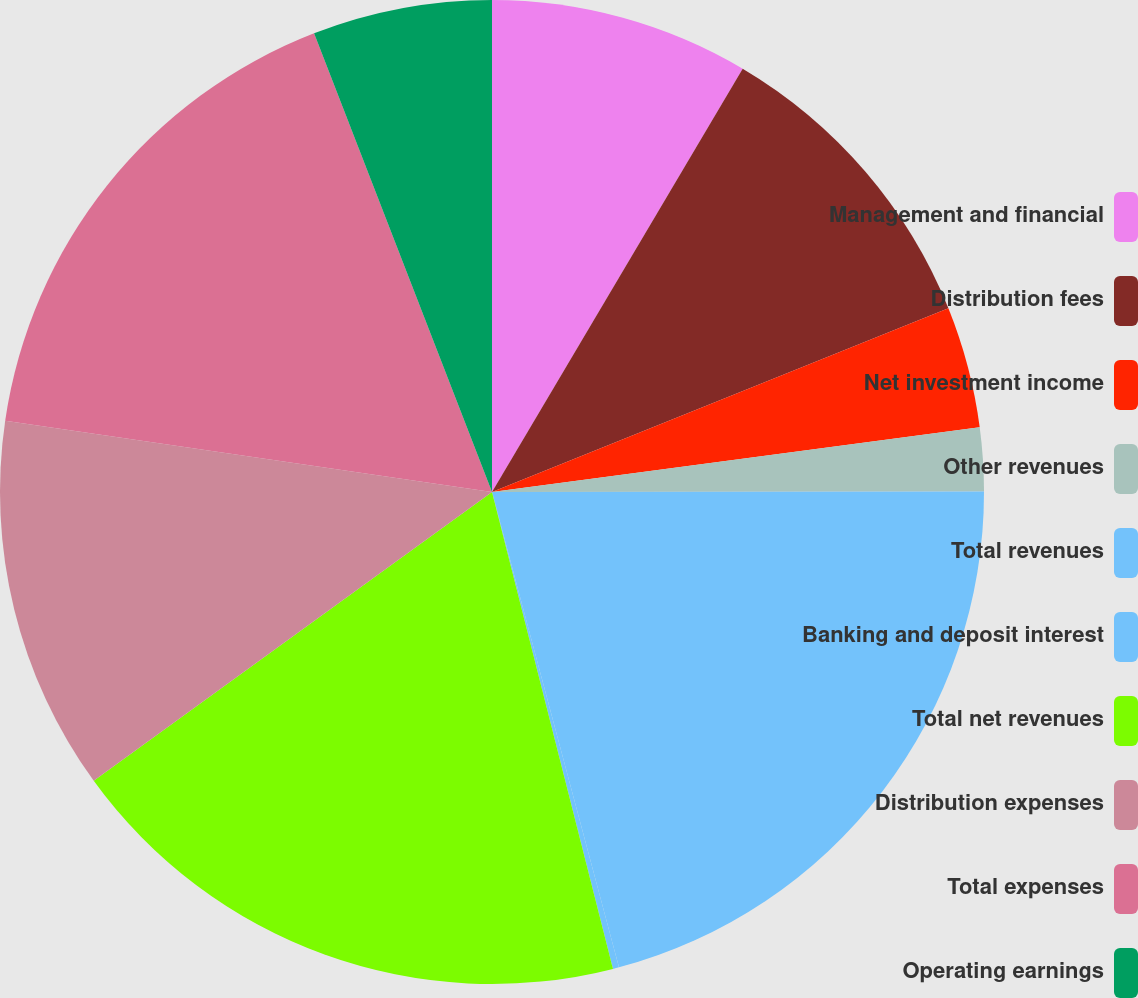<chart> <loc_0><loc_0><loc_500><loc_500><pie_chart><fcel>Management and financial<fcel>Distribution fees<fcel>Net investment income<fcel>Other revenues<fcel>Total revenues<fcel>Banking and deposit interest<fcel>Total net revenues<fcel>Distribution expenses<fcel>Total expenses<fcel>Operating earnings<nl><fcel>8.51%<fcel>10.4%<fcel>3.99%<fcel>2.09%<fcel>20.86%<fcel>0.2%<fcel>18.97%<fcel>12.3%<fcel>16.8%<fcel>5.89%<nl></chart> 